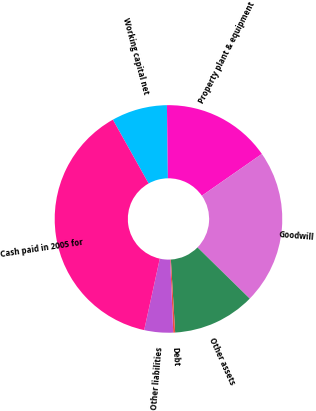<chart> <loc_0><loc_0><loc_500><loc_500><pie_chart><fcel>Working capital net<fcel>Property plant & equipment<fcel>Goodwill<fcel>Other assets<fcel>Debt<fcel>Other liabilities<fcel>Cash paid in 2005 for<nl><fcel>7.91%<fcel>15.54%<fcel>22.02%<fcel>11.72%<fcel>0.27%<fcel>4.09%<fcel>38.44%<nl></chart> 